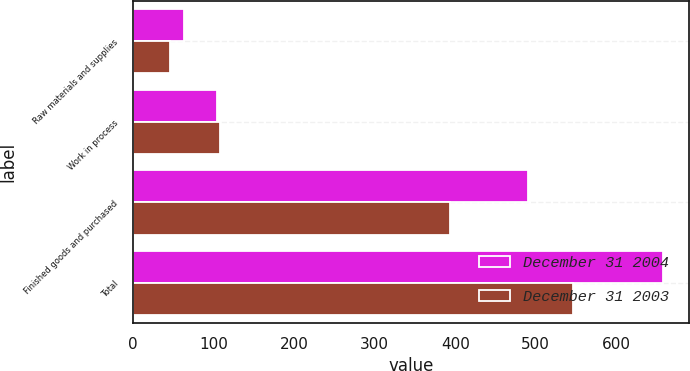<chart> <loc_0><loc_0><loc_500><loc_500><stacked_bar_chart><ecel><fcel>Raw materials and supplies<fcel>Work in process<fcel>Finished goods and purchased<fcel>Total<nl><fcel>December 31 2004<fcel>62.6<fcel>104.2<fcel>490.7<fcel>657.5<nl><fcel>December 31 2003<fcel>45.4<fcel>107.7<fcel>393.6<fcel>546.7<nl></chart> 